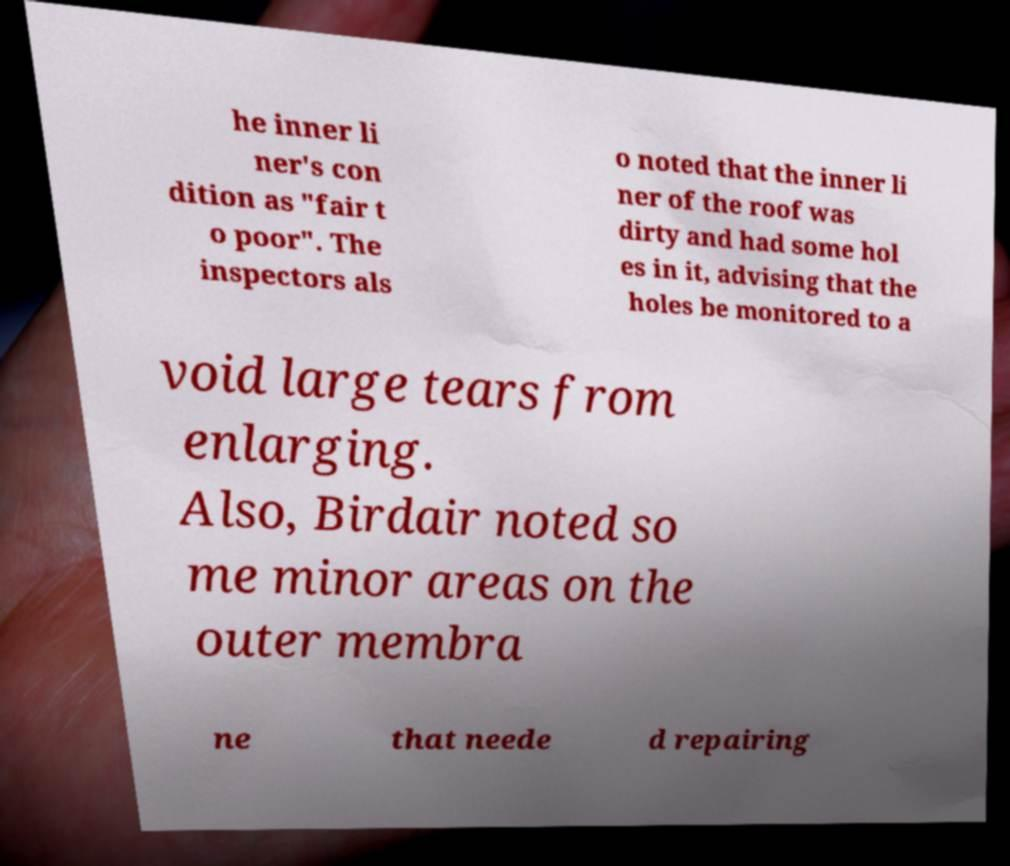I need the written content from this picture converted into text. Can you do that? he inner li ner's con dition as "fair t o poor". The inspectors als o noted that the inner li ner of the roof was dirty and had some hol es in it, advising that the holes be monitored to a void large tears from enlarging. Also, Birdair noted so me minor areas on the outer membra ne that neede d repairing 